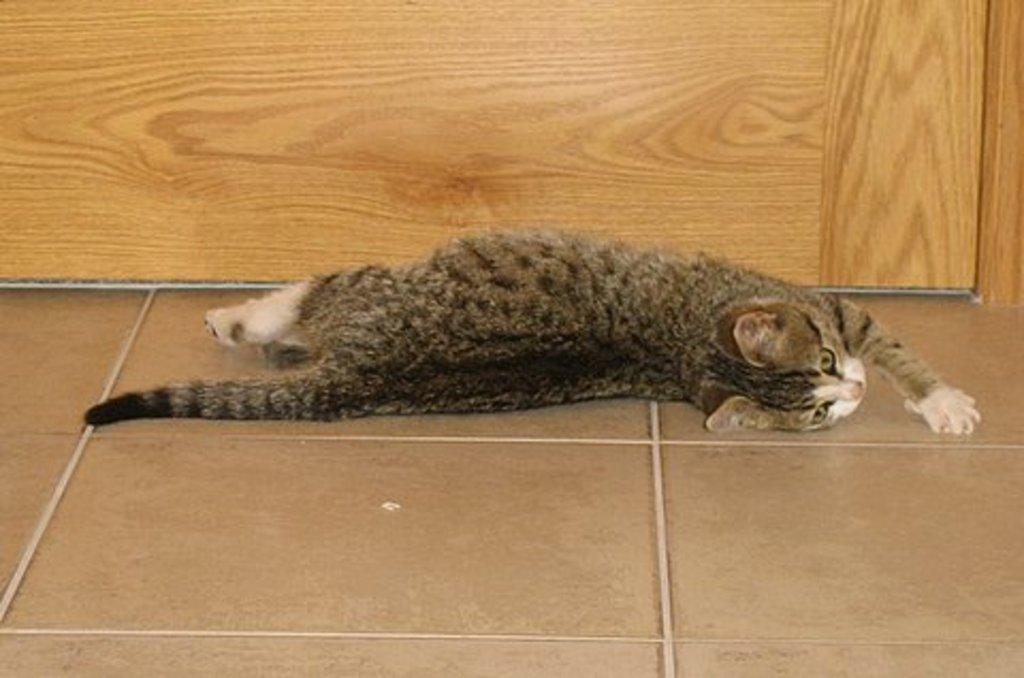What animal is present in the image? There is a cat in the image. What position is the cat in? The cat is laying on the floor. What type of wall can be seen in the background of the image? There is a wooden wall in the background of the image. What type of trousers is the cat wearing in the image? Cats do not wear trousers, so this detail cannot be found in the image. 